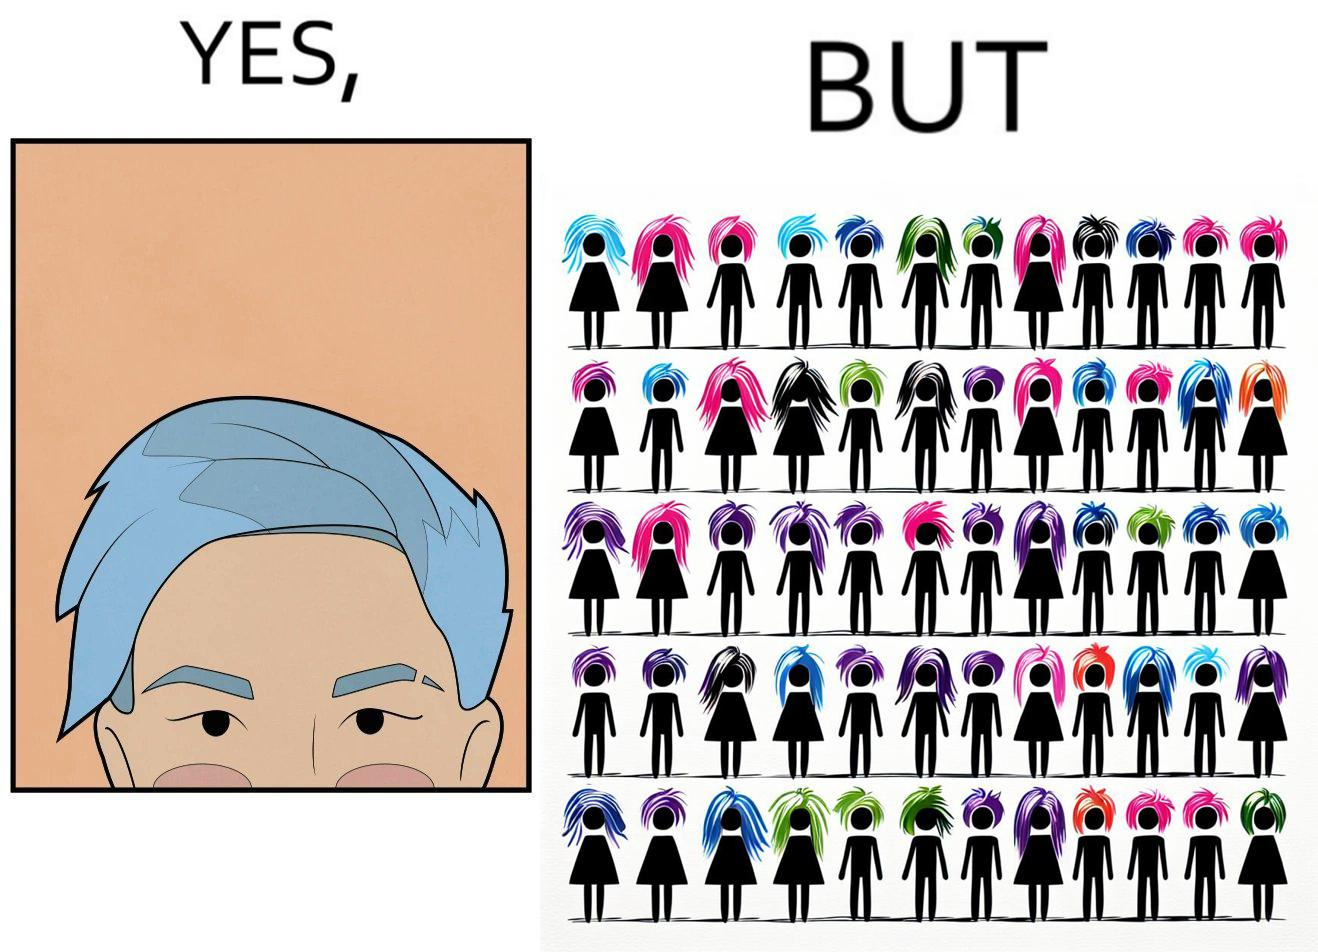Is there satirical content in this image? Yes, this image is satirical. 